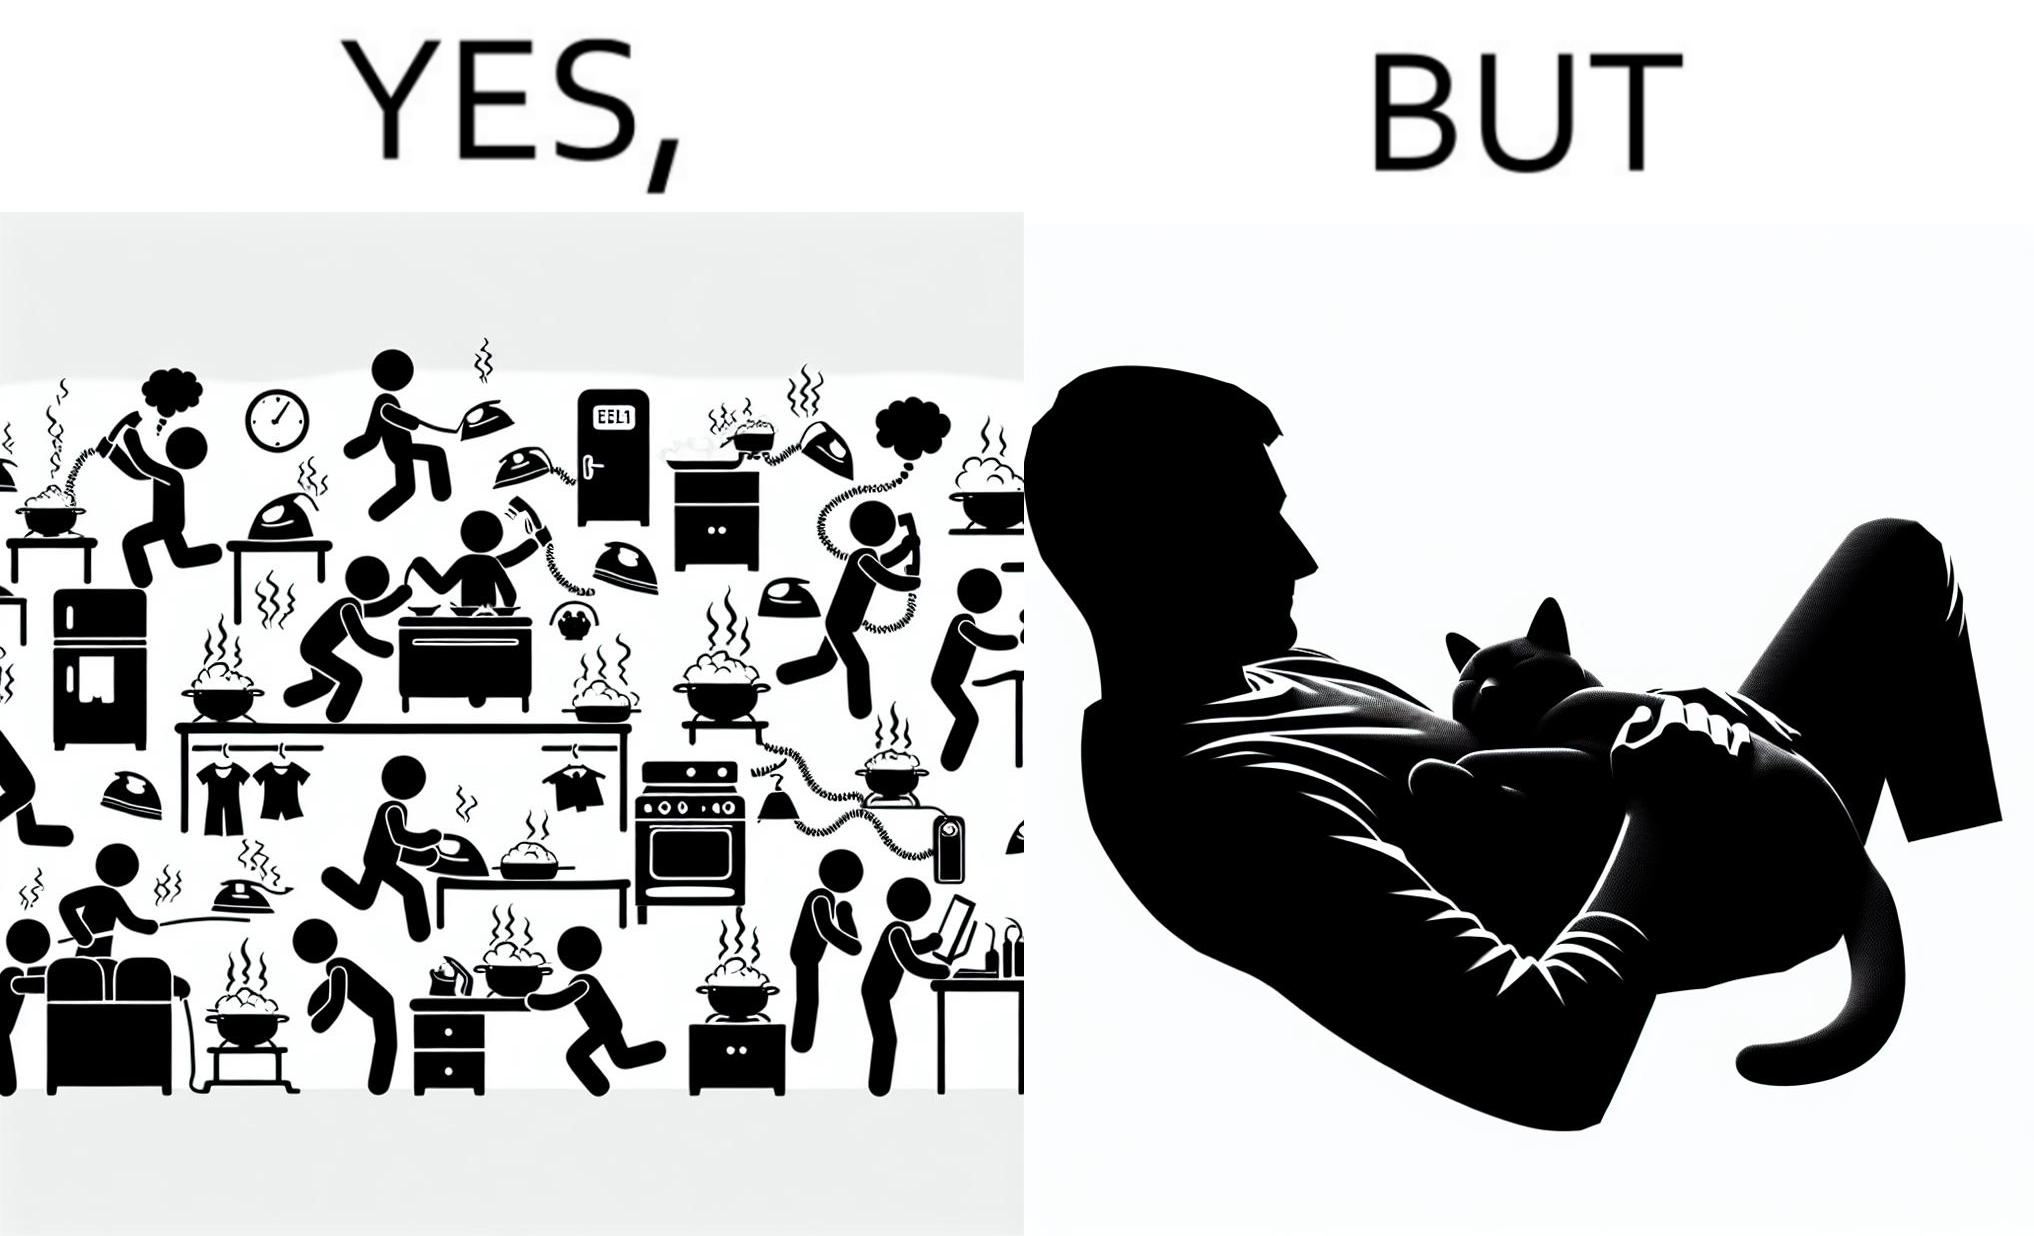Does this image contain satire or humor? Yes, this image is satirical. 